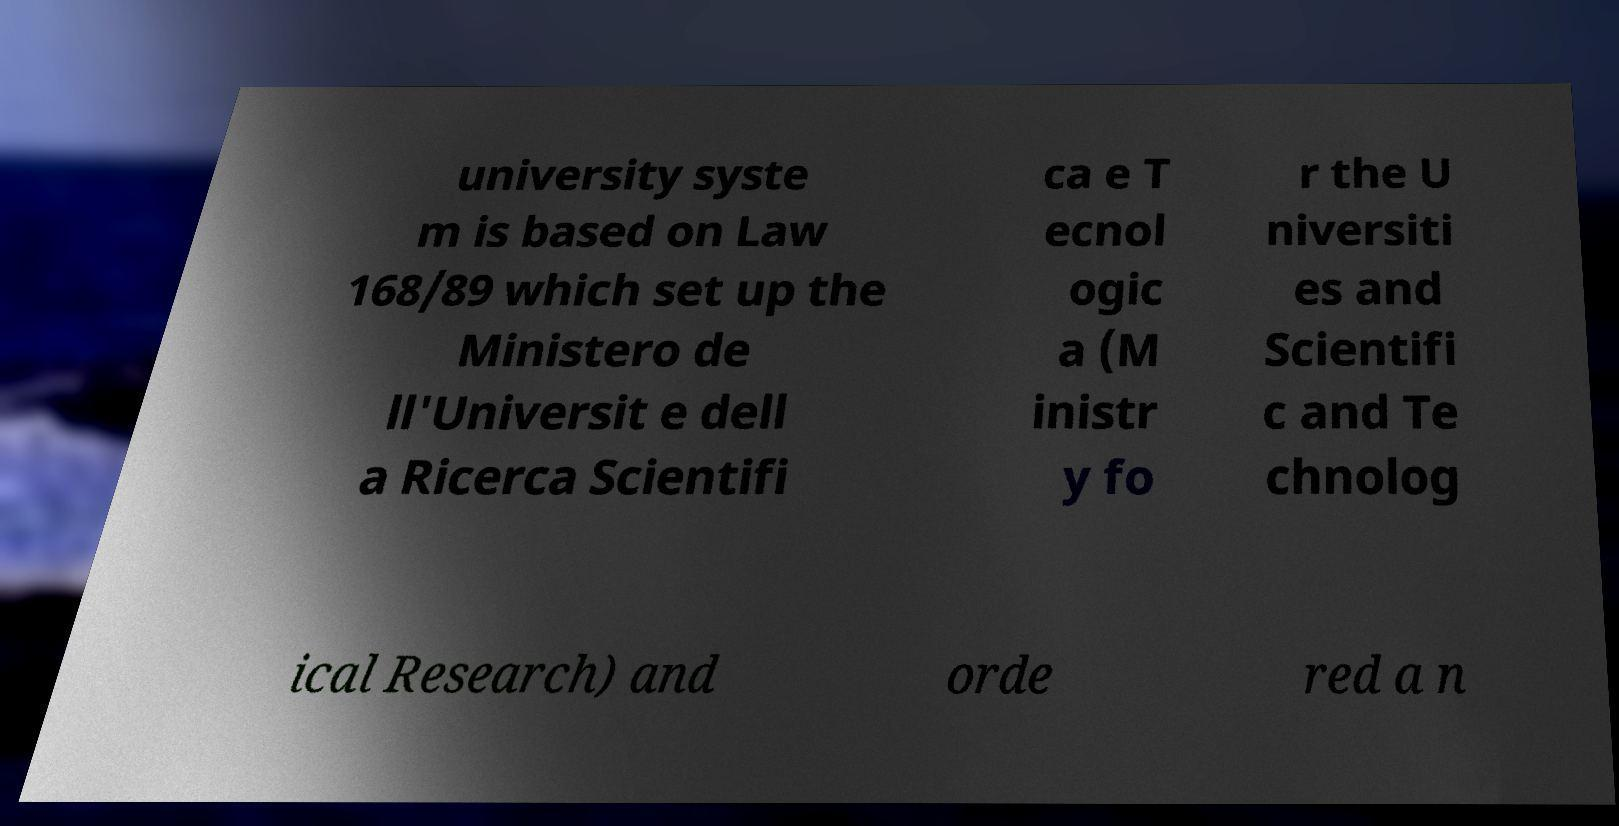Please read and relay the text visible in this image. What does it say? university syste m is based on Law 168/89 which set up the Ministero de ll'Universit e dell a Ricerca Scientifi ca e T ecnol ogic a (M inistr y fo r the U niversiti es and Scientifi c and Te chnolog ical Research) and orde red a n 